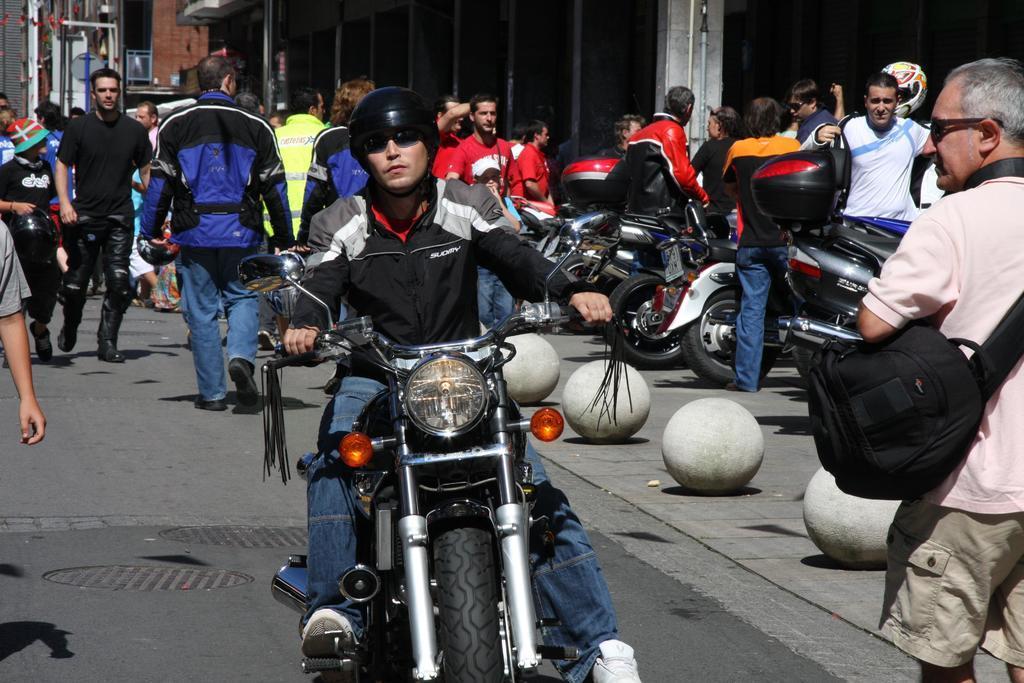Describe this image in one or two sentences. In this image there are group of persons who are standing and at the middle of the image there is a person wearing black color jacket and helmet riding motor cycle. 